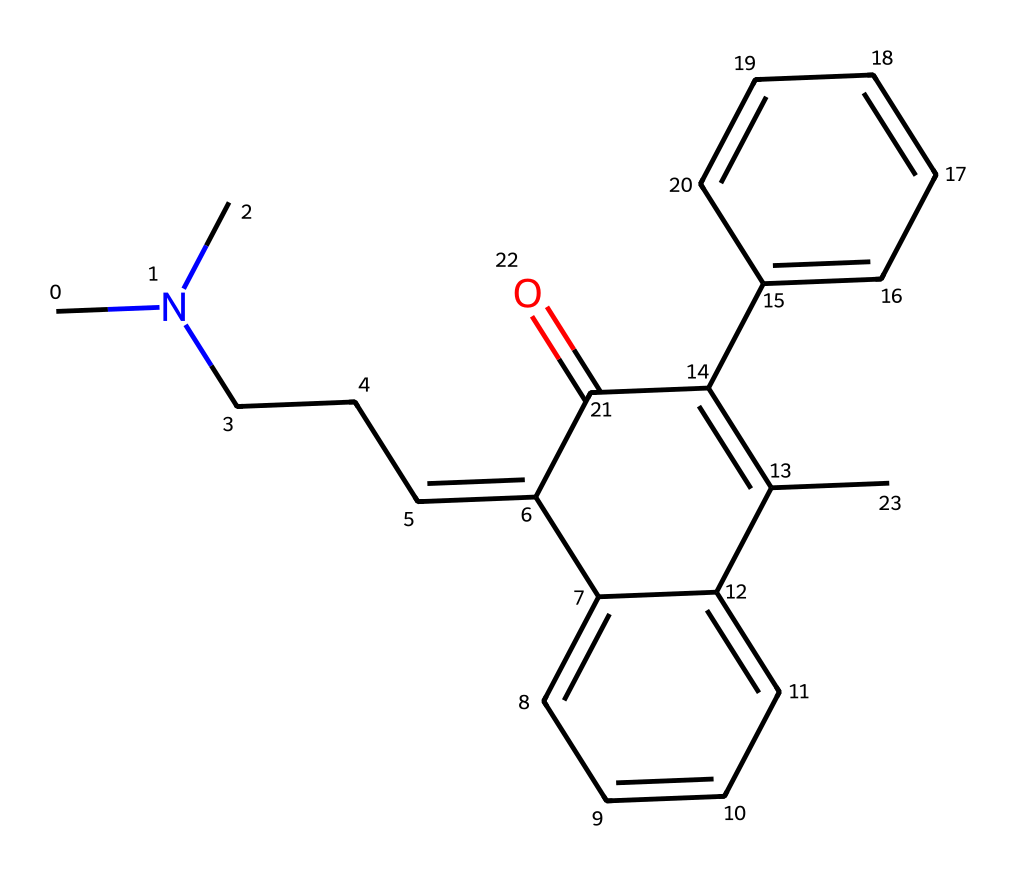What is the molecular formula of cyclobenzaprine? To determine the molecular formula, you need to count the number of each type of atom in the SMILES representation. The structure consists of nitrogen (N), carbon (C), and hydrogen (H) atoms. Counting them gives: C-18, H-22, N-1. Therefore, the molecular formula is C18H22N.
Answer: C18H22N How many rings are present in cyclobenzaprine? Inspecting the structure through the SMILES, we notice the presence of two aromatic rings. The 'c' denotes aromatic carbon atoms, and these form the cyclic structures. Hence, there are two rings in cyclobenzaprine.
Answer: 2 Which functional group is present in cyclobenzaprine? Looking at the SMILES representation, we identify the presence of a ketone functional group, indicated by the carbonyl (C=O) moiety. This is evident in the structure with a carbon double bonded to an oxygen.
Answer: ketone What type of cycloalkane does cyclobenzaprine belong to? By evaluating the structure, we see that cyclobenzaprine features a fused bicyclic system consisting of one non-saturated cyclic structure with double bonds and aromatic rings, classifying it as an aromatic cycloalkane.
Answer: aromatic cycloalkane Is cyclobenzaprine a saturated or unsaturated compound? Examining the presence of double bonds within the carbon chain (C=C), we can conclude that cyclobenzaprine has unsaturation due to these double bonds, indicating it is an unsaturated compound.
Answer: unsaturated What is the primary use of cyclobenzaprine? Cyclobenzaprine is primarily employed as a muscle relaxant, used for the treatment of muscle spasms in conditions related to acute pain, enhancing relaxation in stressed muscles.
Answer: muscle relaxant 